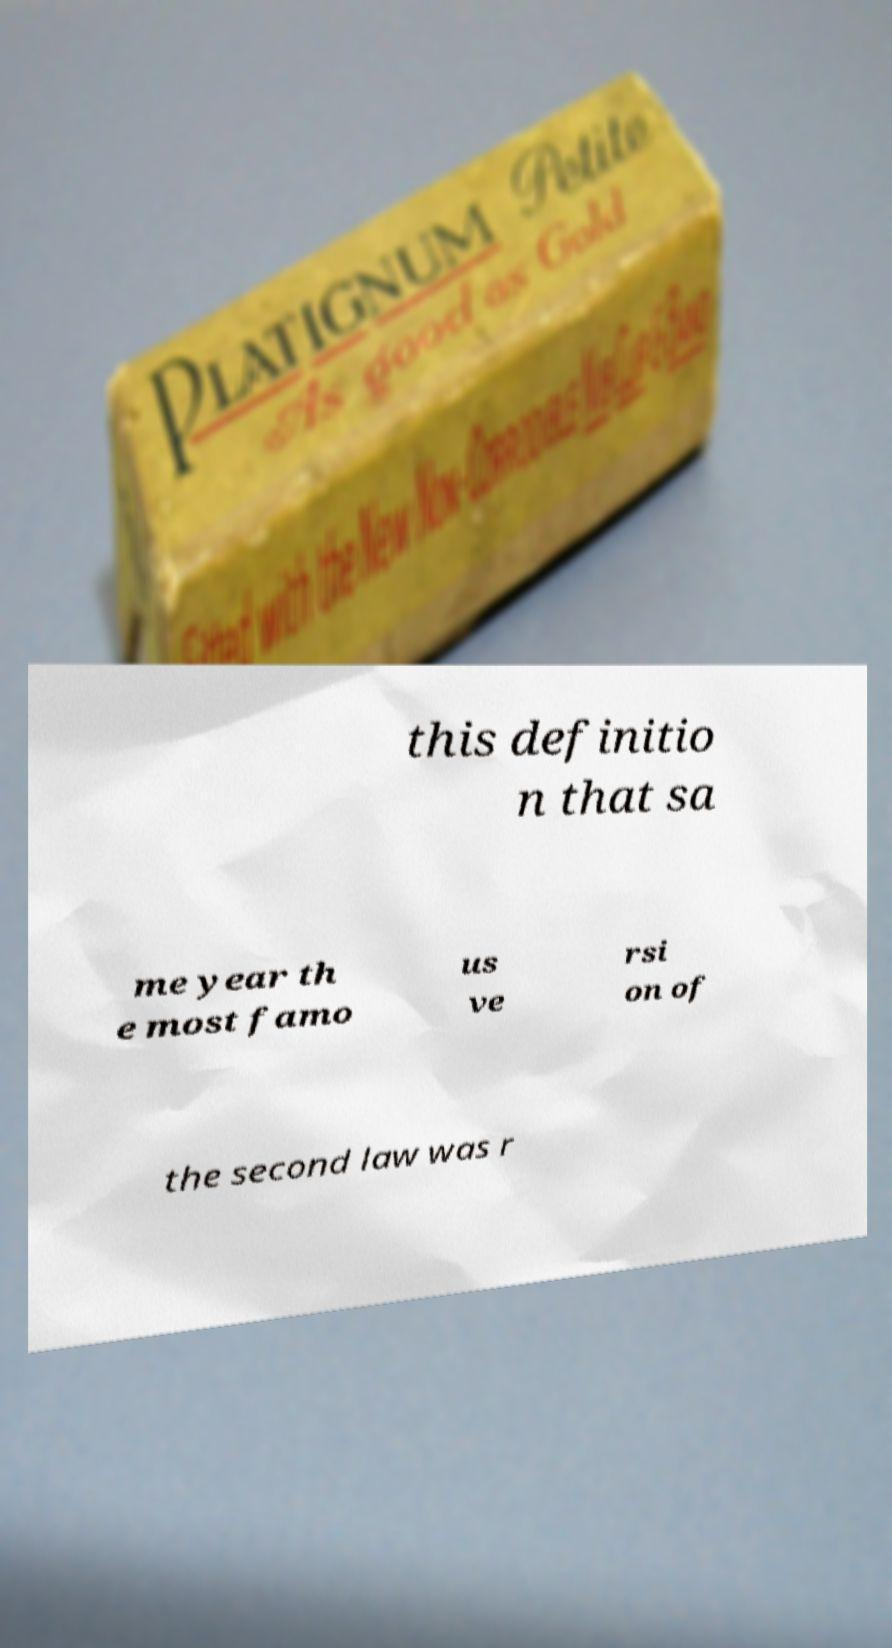For documentation purposes, I need the text within this image transcribed. Could you provide that? this definitio n that sa me year th e most famo us ve rsi on of the second law was r 